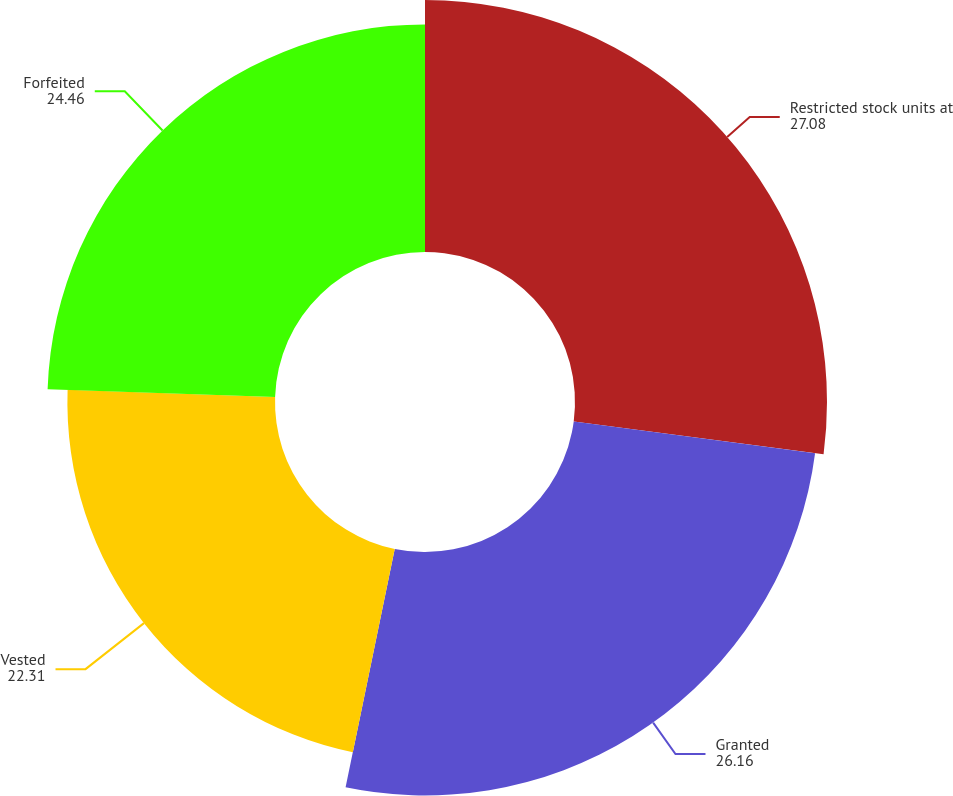Convert chart. <chart><loc_0><loc_0><loc_500><loc_500><pie_chart><fcel>Restricted stock units at<fcel>Granted<fcel>Vested<fcel>Forfeited<nl><fcel>27.08%<fcel>26.16%<fcel>22.31%<fcel>24.46%<nl></chart> 